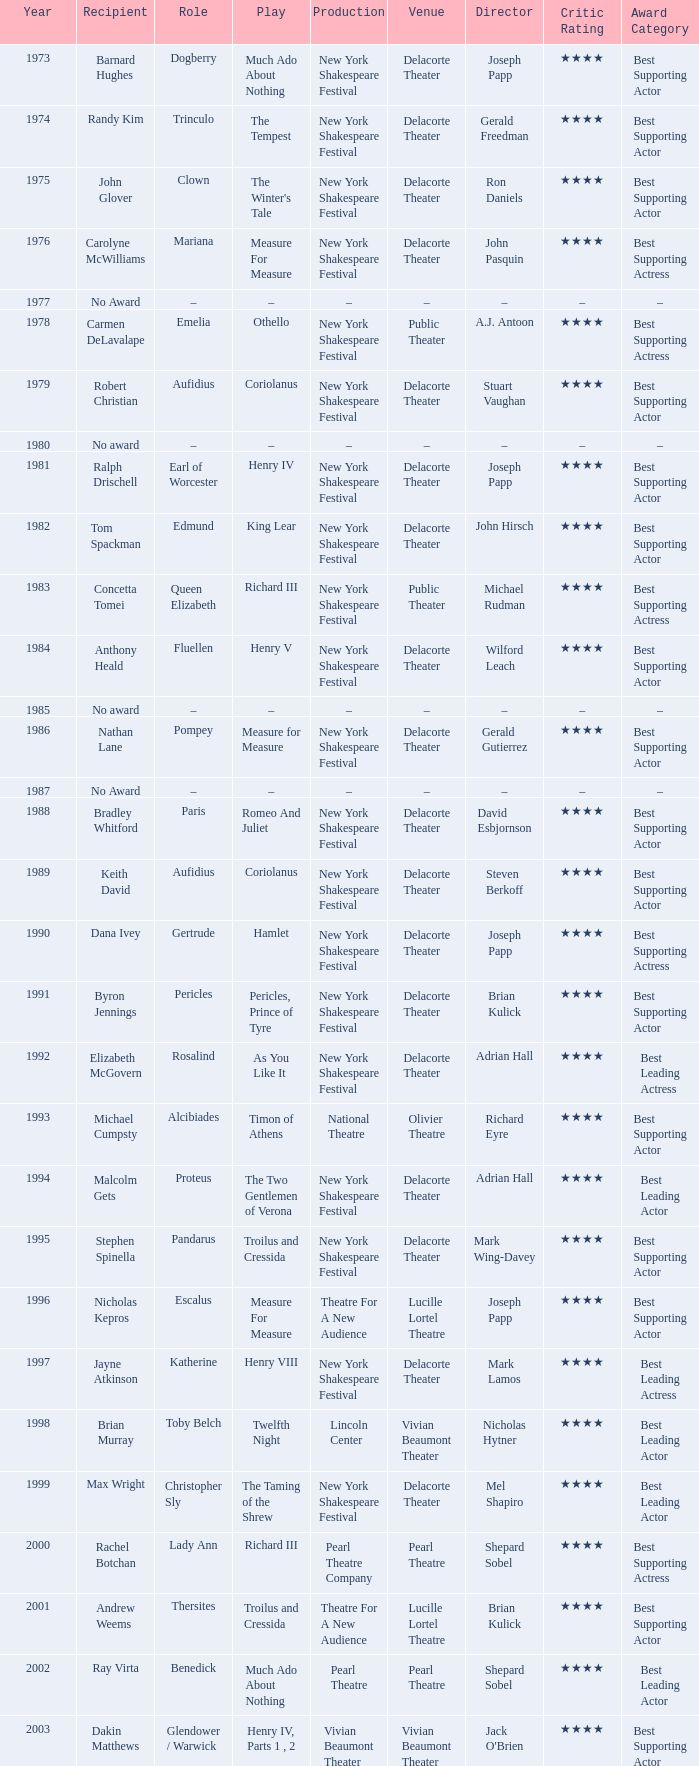Name the recipient of much ado about nothing for 1973 Barnard Hughes. 